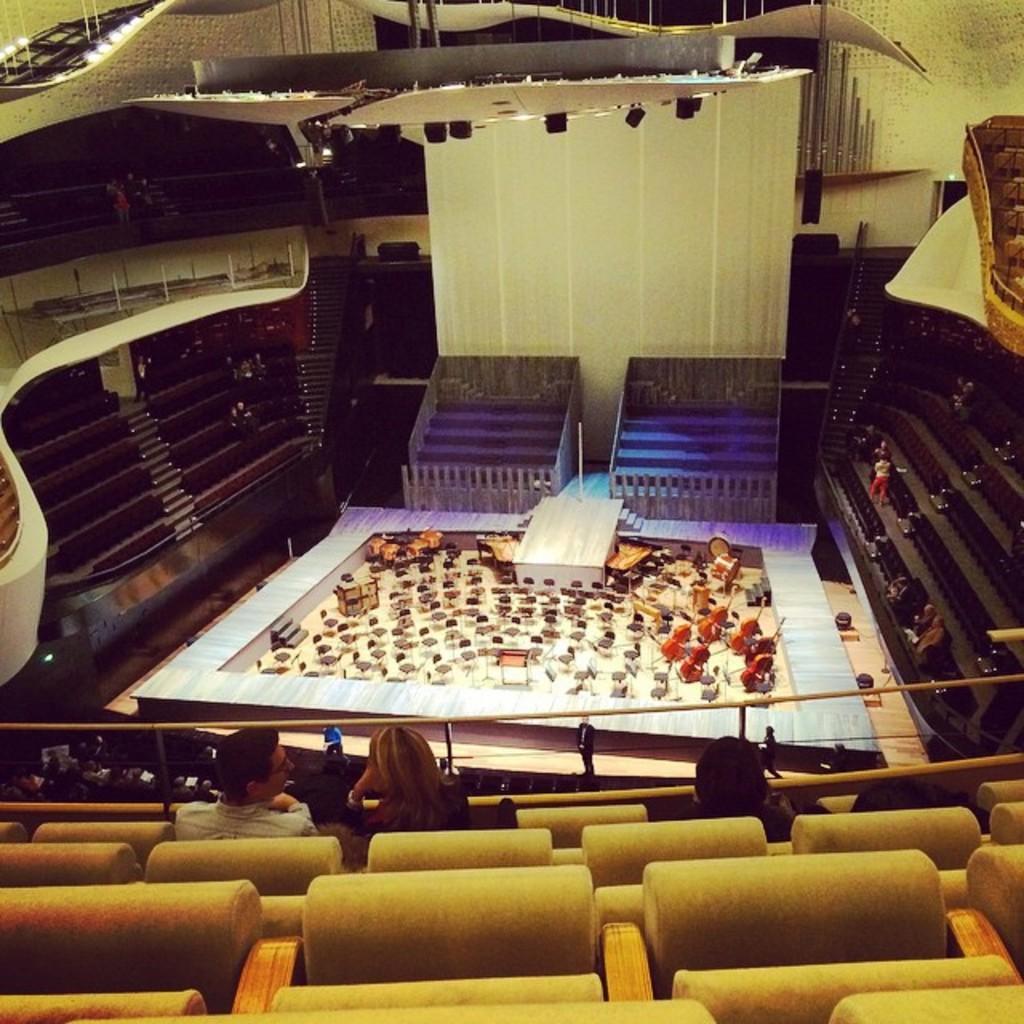Could you give a brief overview of what you see in this image? This is an inside view of an auditorium. At the bottom few people are sitting on the chairs and also there are some empty chairs. In the center of the image there are some chairs and musical instruments are placed on the floor. On the right and left sides of the image I can see the stairs. In the background there is a wall. 